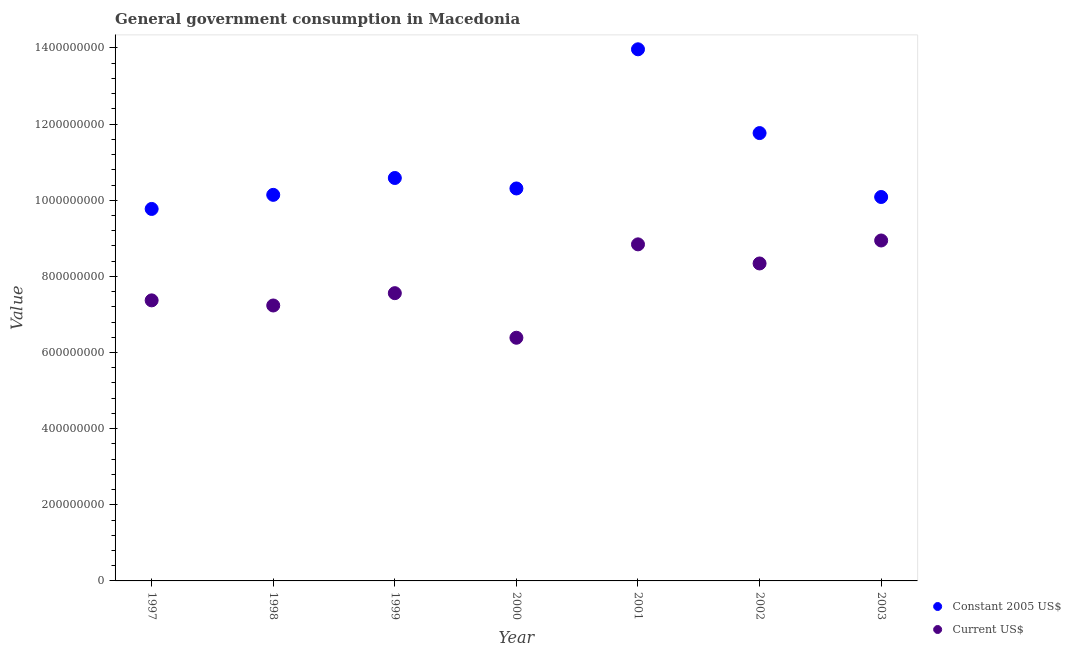How many different coloured dotlines are there?
Offer a very short reply. 2. What is the value consumed in current us$ in 2002?
Provide a short and direct response. 8.34e+08. Across all years, what is the maximum value consumed in constant 2005 us$?
Offer a very short reply. 1.40e+09. Across all years, what is the minimum value consumed in current us$?
Give a very brief answer. 6.39e+08. In which year was the value consumed in current us$ maximum?
Provide a succinct answer. 2003. In which year was the value consumed in constant 2005 us$ minimum?
Provide a succinct answer. 1997. What is the total value consumed in current us$ in the graph?
Keep it short and to the point. 5.47e+09. What is the difference between the value consumed in current us$ in 1998 and that in 2003?
Make the answer very short. -1.71e+08. What is the difference between the value consumed in constant 2005 us$ in 2003 and the value consumed in current us$ in 2002?
Offer a terse response. 1.75e+08. What is the average value consumed in current us$ per year?
Make the answer very short. 7.81e+08. In the year 2001, what is the difference between the value consumed in constant 2005 us$ and value consumed in current us$?
Keep it short and to the point. 5.12e+08. What is the ratio of the value consumed in current us$ in 1999 to that in 2002?
Provide a succinct answer. 0.91. Is the difference between the value consumed in current us$ in 2001 and 2002 greater than the difference between the value consumed in constant 2005 us$ in 2001 and 2002?
Offer a terse response. No. What is the difference between the highest and the second highest value consumed in current us$?
Give a very brief answer. 1.02e+07. What is the difference between the highest and the lowest value consumed in constant 2005 us$?
Give a very brief answer. 4.19e+08. Is the sum of the value consumed in constant 2005 us$ in 1999 and 2001 greater than the maximum value consumed in current us$ across all years?
Provide a short and direct response. Yes. Does the value consumed in current us$ monotonically increase over the years?
Give a very brief answer. No. Is the value consumed in current us$ strictly greater than the value consumed in constant 2005 us$ over the years?
Keep it short and to the point. No. Is the value consumed in constant 2005 us$ strictly less than the value consumed in current us$ over the years?
Provide a short and direct response. No. How many dotlines are there?
Your response must be concise. 2. How many years are there in the graph?
Provide a succinct answer. 7. Are the values on the major ticks of Y-axis written in scientific E-notation?
Keep it short and to the point. No. Does the graph contain any zero values?
Ensure brevity in your answer.  No. Does the graph contain grids?
Your answer should be very brief. No. Where does the legend appear in the graph?
Make the answer very short. Bottom right. What is the title of the graph?
Your answer should be very brief. General government consumption in Macedonia. Does "Tetanus" appear as one of the legend labels in the graph?
Your answer should be very brief. No. What is the label or title of the X-axis?
Provide a succinct answer. Year. What is the label or title of the Y-axis?
Provide a succinct answer. Value. What is the Value in Constant 2005 US$ in 1997?
Offer a terse response. 9.77e+08. What is the Value in Current US$ in 1997?
Keep it short and to the point. 7.37e+08. What is the Value in Constant 2005 US$ in 1998?
Give a very brief answer. 1.01e+09. What is the Value of Current US$ in 1998?
Ensure brevity in your answer.  7.24e+08. What is the Value of Constant 2005 US$ in 1999?
Provide a short and direct response. 1.06e+09. What is the Value in Current US$ in 1999?
Keep it short and to the point. 7.56e+08. What is the Value of Constant 2005 US$ in 2000?
Your response must be concise. 1.03e+09. What is the Value of Current US$ in 2000?
Make the answer very short. 6.39e+08. What is the Value in Constant 2005 US$ in 2001?
Ensure brevity in your answer.  1.40e+09. What is the Value in Current US$ in 2001?
Ensure brevity in your answer.  8.84e+08. What is the Value of Constant 2005 US$ in 2002?
Keep it short and to the point. 1.18e+09. What is the Value in Current US$ in 2002?
Your answer should be compact. 8.34e+08. What is the Value of Constant 2005 US$ in 2003?
Provide a succinct answer. 1.01e+09. What is the Value of Current US$ in 2003?
Keep it short and to the point. 8.94e+08. Across all years, what is the maximum Value in Constant 2005 US$?
Your response must be concise. 1.40e+09. Across all years, what is the maximum Value of Current US$?
Offer a very short reply. 8.94e+08. Across all years, what is the minimum Value in Constant 2005 US$?
Keep it short and to the point. 9.77e+08. Across all years, what is the minimum Value of Current US$?
Provide a short and direct response. 6.39e+08. What is the total Value in Constant 2005 US$ in the graph?
Your response must be concise. 7.66e+09. What is the total Value in Current US$ in the graph?
Offer a very short reply. 5.47e+09. What is the difference between the Value of Constant 2005 US$ in 1997 and that in 1998?
Your answer should be very brief. -3.70e+07. What is the difference between the Value of Current US$ in 1997 and that in 1998?
Give a very brief answer. 1.34e+07. What is the difference between the Value of Constant 2005 US$ in 1997 and that in 1999?
Provide a short and direct response. -8.13e+07. What is the difference between the Value in Current US$ in 1997 and that in 1999?
Offer a terse response. -1.89e+07. What is the difference between the Value in Constant 2005 US$ in 1997 and that in 2000?
Provide a succinct answer. -5.38e+07. What is the difference between the Value in Current US$ in 1997 and that in 2000?
Your response must be concise. 9.82e+07. What is the difference between the Value in Constant 2005 US$ in 1997 and that in 2001?
Keep it short and to the point. -4.19e+08. What is the difference between the Value in Current US$ in 1997 and that in 2001?
Make the answer very short. -1.47e+08. What is the difference between the Value of Constant 2005 US$ in 1997 and that in 2002?
Provide a short and direct response. -1.99e+08. What is the difference between the Value of Current US$ in 1997 and that in 2002?
Your answer should be very brief. -9.69e+07. What is the difference between the Value of Constant 2005 US$ in 1997 and that in 2003?
Keep it short and to the point. -3.14e+07. What is the difference between the Value of Current US$ in 1997 and that in 2003?
Your answer should be compact. -1.57e+08. What is the difference between the Value in Constant 2005 US$ in 1998 and that in 1999?
Provide a short and direct response. -4.43e+07. What is the difference between the Value in Current US$ in 1998 and that in 1999?
Your response must be concise. -3.24e+07. What is the difference between the Value of Constant 2005 US$ in 1998 and that in 2000?
Your answer should be compact. -1.68e+07. What is the difference between the Value in Current US$ in 1998 and that in 2000?
Ensure brevity in your answer.  8.48e+07. What is the difference between the Value of Constant 2005 US$ in 1998 and that in 2001?
Provide a succinct answer. -3.82e+08. What is the difference between the Value in Current US$ in 1998 and that in 2001?
Your response must be concise. -1.61e+08. What is the difference between the Value of Constant 2005 US$ in 1998 and that in 2002?
Ensure brevity in your answer.  -1.62e+08. What is the difference between the Value in Current US$ in 1998 and that in 2002?
Ensure brevity in your answer.  -1.10e+08. What is the difference between the Value of Constant 2005 US$ in 1998 and that in 2003?
Your response must be concise. 5.63e+06. What is the difference between the Value in Current US$ in 1998 and that in 2003?
Your answer should be very brief. -1.71e+08. What is the difference between the Value in Constant 2005 US$ in 1999 and that in 2000?
Offer a terse response. 2.75e+07. What is the difference between the Value in Current US$ in 1999 and that in 2000?
Your answer should be compact. 1.17e+08. What is the difference between the Value in Constant 2005 US$ in 1999 and that in 2001?
Your answer should be very brief. -3.38e+08. What is the difference between the Value in Current US$ in 1999 and that in 2001?
Give a very brief answer. -1.28e+08. What is the difference between the Value in Constant 2005 US$ in 1999 and that in 2002?
Your response must be concise. -1.18e+08. What is the difference between the Value of Current US$ in 1999 and that in 2002?
Offer a terse response. -7.80e+07. What is the difference between the Value in Constant 2005 US$ in 1999 and that in 2003?
Your answer should be compact. 4.99e+07. What is the difference between the Value of Current US$ in 1999 and that in 2003?
Ensure brevity in your answer.  -1.38e+08. What is the difference between the Value in Constant 2005 US$ in 2000 and that in 2001?
Offer a very short reply. -3.66e+08. What is the difference between the Value of Current US$ in 2000 and that in 2001?
Offer a terse response. -2.45e+08. What is the difference between the Value of Constant 2005 US$ in 2000 and that in 2002?
Ensure brevity in your answer.  -1.45e+08. What is the difference between the Value in Current US$ in 2000 and that in 2002?
Your answer should be very brief. -1.95e+08. What is the difference between the Value in Constant 2005 US$ in 2000 and that in 2003?
Give a very brief answer. 2.24e+07. What is the difference between the Value of Current US$ in 2000 and that in 2003?
Make the answer very short. -2.55e+08. What is the difference between the Value in Constant 2005 US$ in 2001 and that in 2002?
Make the answer very short. 2.20e+08. What is the difference between the Value of Current US$ in 2001 and that in 2002?
Offer a very short reply. 5.02e+07. What is the difference between the Value in Constant 2005 US$ in 2001 and that in 2003?
Provide a short and direct response. 3.88e+08. What is the difference between the Value in Current US$ in 2001 and that in 2003?
Keep it short and to the point. -1.02e+07. What is the difference between the Value in Constant 2005 US$ in 2002 and that in 2003?
Your answer should be very brief. 1.68e+08. What is the difference between the Value of Current US$ in 2002 and that in 2003?
Ensure brevity in your answer.  -6.04e+07. What is the difference between the Value in Constant 2005 US$ in 1997 and the Value in Current US$ in 1998?
Keep it short and to the point. 2.54e+08. What is the difference between the Value of Constant 2005 US$ in 1997 and the Value of Current US$ in 1999?
Keep it short and to the point. 2.21e+08. What is the difference between the Value of Constant 2005 US$ in 1997 and the Value of Current US$ in 2000?
Offer a terse response. 3.38e+08. What is the difference between the Value of Constant 2005 US$ in 1997 and the Value of Current US$ in 2001?
Keep it short and to the point. 9.30e+07. What is the difference between the Value of Constant 2005 US$ in 1997 and the Value of Current US$ in 2002?
Keep it short and to the point. 1.43e+08. What is the difference between the Value in Constant 2005 US$ in 1997 and the Value in Current US$ in 2003?
Give a very brief answer. 8.29e+07. What is the difference between the Value of Constant 2005 US$ in 1998 and the Value of Current US$ in 1999?
Your response must be concise. 2.58e+08. What is the difference between the Value in Constant 2005 US$ in 1998 and the Value in Current US$ in 2000?
Ensure brevity in your answer.  3.75e+08. What is the difference between the Value of Constant 2005 US$ in 1998 and the Value of Current US$ in 2001?
Keep it short and to the point. 1.30e+08. What is the difference between the Value of Constant 2005 US$ in 1998 and the Value of Current US$ in 2002?
Keep it short and to the point. 1.80e+08. What is the difference between the Value of Constant 2005 US$ in 1998 and the Value of Current US$ in 2003?
Your answer should be compact. 1.20e+08. What is the difference between the Value in Constant 2005 US$ in 1999 and the Value in Current US$ in 2000?
Make the answer very short. 4.20e+08. What is the difference between the Value in Constant 2005 US$ in 1999 and the Value in Current US$ in 2001?
Ensure brevity in your answer.  1.74e+08. What is the difference between the Value in Constant 2005 US$ in 1999 and the Value in Current US$ in 2002?
Your response must be concise. 2.25e+08. What is the difference between the Value in Constant 2005 US$ in 1999 and the Value in Current US$ in 2003?
Your response must be concise. 1.64e+08. What is the difference between the Value in Constant 2005 US$ in 2000 and the Value in Current US$ in 2001?
Your response must be concise. 1.47e+08. What is the difference between the Value in Constant 2005 US$ in 2000 and the Value in Current US$ in 2002?
Make the answer very short. 1.97e+08. What is the difference between the Value of Constant 2005 US$ in 2000 and the Value of Current US$ in 2003?
Keep it short and to the point. 1.37e+08. What is the difference between the Value of Constant 2005 US$ in 2001 and the Value of Current US$ in 2002?
Provide a short and direct response. 5.63e+08. What is the difference between the Value of Constant 2005 US$ in 2001 and the Value of Current US$ in 2003?
Ensure brevity in your answer.  5.02e+08. What is the difference between the Value of Constant 2005 US$ in 2002 and the Value of Current US$ in 2003?
Your answer should be compact. 2.82e+08. What is the average Value in Constant 2005 US$ per year?
Your answer should be compact. 1.09e+09. What is the average Value of Current US$ per year?
Provide a succinct answer. 7.81e+08. In the year 1997, what is the difference between the Value in Constant 2005 US$ and Value in Current US$?
Offer a terse response. 2.40e+08. In the year 1998, what is the difference between the Value in Constant 2005 US$ and Value in Current US$?
Offer a very short reply. 2.91e+08. In the year 1999, what is the difference between the Value in Constant 2005 US$ and Value in Current US$?
Your answer should be compact. 3.03e+08. In the year 2000, what is the difference between the Value in Constant 2005 US$ and Value in Current US$?
Your answer should be very brief. 3.92e+08. In the year 2001, what is the difference between the Value in Constant 2005 US$ and Value in Current US$?
Keep it short and to the point. 5.12e+08. In the year 2002, what is the difference between the Value in Constant 2005 US$ and Value in Current US$?
Your answer should be compact. 3.42e+08. In the year 2003, what is the difference between the Value in Constant 2005 US$ and Value in Current US$?
Give a very brief answer. 1.14e+08. What is the ratio of the Value in Constant 2005 US$ in 1997 to that in 1998?
Provide a short and direct response. 0.96. What is the ratio of the Value in Current US$ in 1997 to that in 1998?
Give a very brief answer. 1.02. What is the ratio of the Value of Constant 2005 US$ in 1997 to that in 1999?
Your answer should be very brief. 0.92. What is the ratio of the Value in Current US$ in 1997 to that in 1999?
Your response must be concise. 0.97. What is the ratio of the Value of Constant 2005 US$ in 1997 to that in 2000?
Your answer should be compact. 0.95. What is the ratio of the Value in Current US$ in 1997 to that in 2000?
Provide a succinct answer. 1.15. What is the ratio of the Value in Constant 2005 US$ in 1997 to that in 2001?
Offer a terse response. 0.7. What is the ratio of the Value in Current US$ in 1997 to that in 2001?
Ensure brevity in your answer.  0.83. What is the ratio of the Value of Constant 2005 US$ in 1997 to that in 2002?
Offer a terse response. 0.83. What is the ratio of the Value in Current US$ in 1997 to that in 2002?
Your response must be concise. 0.88. What is the ratio of the Value in Constant 2005 US$ in 1997 to that in 2003?
Your response must be concise. 0.97. What is the ratio of the Value in Current US$ in 1997 to that in 2003?
Make the answer very short. 0.82. What is the ratio of the Value of Constant 2005 US$ in 1998 to that in 1999?
Provide a short and direct response. 0.96. What is the ratio of the Value in Current US$ in 1998 to that in 1999?
Your answer should be compact. 0.96. What is the ratio of the Value in Constant 2005 US$ in 1998 to that in 2000?
Your answer should be compact. 0.98. What is the ratio of the Value of Current US$ in 1998 to that in 2000?
Provide a short and direct response. 1.13. What is the ratio of the Value in Constant 2005 US$ in 1998 to that in 2001?
Offer a terse response. 0.73. What is the ratio of the Value in Current US$ in 1998 to that in 2001?
Ensure brevity in your answer.  0.82. What is the ratio of the Value in Constant 2005 US$ in 1998 to that in 2002?
Offer a very short reply. 0.86. What is the ratio of the Value of Current US$ in 1998 to that in 2002?
Your answer should be compact. 0.87. What is the ratio of the Value in Constant 2005 US$ in 1998 to that in 2003?
Provide a succinct answer. 1.01. What is the ratio of the Value of Current US$ in 1998 to that in 2003?
Provide a succinct answer. 0.81. What is the ratio of the Value in Constant 2005 US$ in 1999 to that in 2000?
Offer a terse response. 1.03. What is the ratio of the Value in Current US$ in 1999 to that in 2000?
Make the answer very short. 1.18. What is the ratio of the Value in Constant 2005 US$ in 1999 to that in 2001?
Give a very brief answer. 0.76. What is the ratio of the Value of Current US$ in 1999 to that in 2001?
Give a very brief answer. 0.85. What is the ratio of the Value of Constant 2005 US$ in 1999 to that in 2002?
Offer a very short reply. 0.9. What is the ratio of the Value of Current US$ in 1999 to that in 2002?
Give a very brief answer. 0.91. What is the ratio of the Value of Constant 2005 US$ in 1999 to that in 2003?
Offer a very short reply. 1.05. What is the ratio of the Value in Current US$ in 1999 to that in 2003?
Offer a terse response. 0.85. What is the ratio of the Value in Constant 2005 US$ in 2000 to that in 2001?
Make the answer very short. 0.74. What is the ratio of the Value of Current US$ in 2000 to that in 2001?
Provide a succinct answer. 0.72. What is the ratio of the Value in Constant 2005 US$ in 2000 to that in 2002?
Ensure brevity in your answer.  0.88. What is the ratio of the Value of Current US$ in 2000 to that in 2002?
Your answer should be compact. 0.77. What is the ratio of the Value of Constant 2005 US$ in 2000 to that in 2003?
Ensure brevity in your answer.  1.02. What is the ratio of the Value of Constant 2005 US$ in 2001 to that in 2002?
Offer a terse response. 1.19. What is the ratio of the Value of Current US$ in 2001 to that in 2002?
Keep it short and to the point. 1.06. What is the ratio of the Value in Constant 2005 US$ in 2001 to that in 2003?
Offer a terse response. 1.38. What is the ratio of the Value of Current US$ in 2001 to that in 2003?
Offer a very short reply. 0.99. What is the ratio of the Value of Constant 2005 US$ in 2002 to that in 2003?
Offer a terse response. 1.17. What is the ratio of the Value in Current US$ in 2002 to that in 2003?
Give a very brief answer. 0.93. What is the difference between the highest and the second highest Value of Constant 2005 US$?
Give a very brief answer. 2.20e+08. What is the difference between the highest and the second highest Value of Current US$?
Keep it short and to the point. 1.02e+07. What is the difference between the highest and the lowest Value in Constant 2005 US$?
Your answer should be very brief. 4.19e+08. What is the difference between the highest and the lowest Value of Current US$?
Make the answer very short. 2.55e+08. 